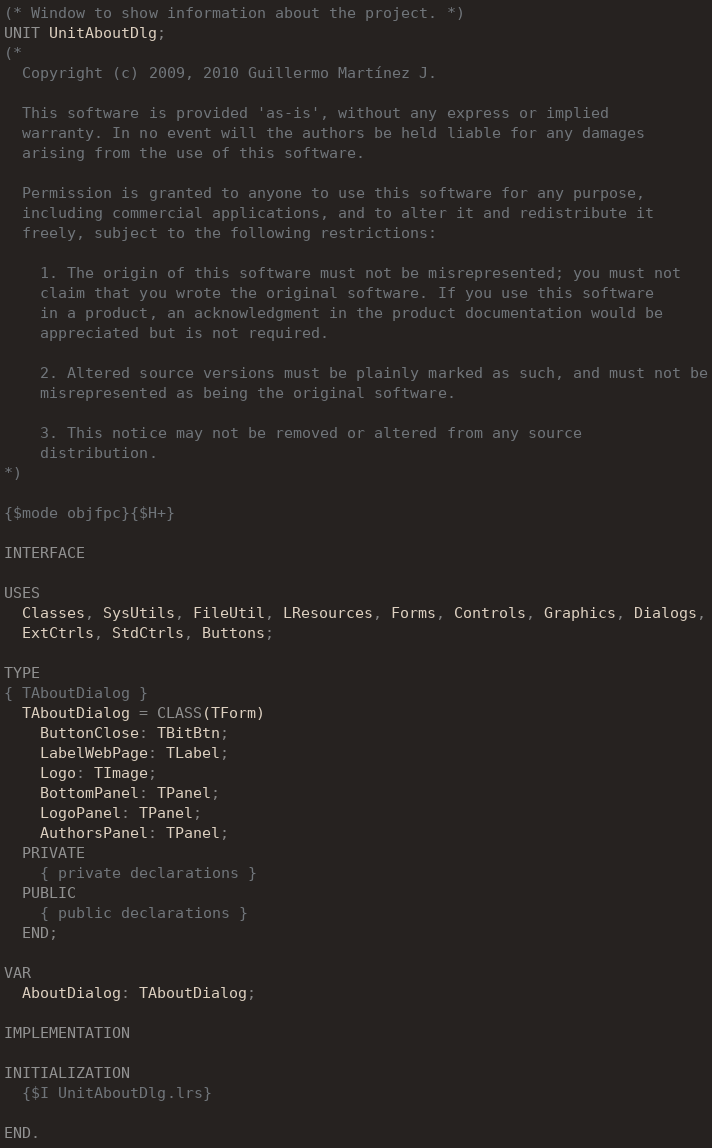Convert code to text. <code><loc_0><loc_0><loc_500><loc_500><_Pascal_>(* Window to show information about the project. *)
UNIT UnitAboutDlg;
(*
  Copyright (c) 2009, 2010 Guillermo Martínez J.

  This software is provided 'as-is', without any express or implied
  warranty. In no event will the authors be held liable for any damages
  arising from the use of this software.

  Permission is granted to anyone to use this software for any purpose,
  including commercial applications, and to alter it and redistribute it
  freely, subject to the following restrictions:

    1. The origin of this software must not be misrepresented; you must not
    claim that you wrote the original software. If you use this software
    in a product, an acknowledgment in the product documentation would be
    appreciated but is not required.

    2. Altered source versions must be plainly marked as such, and must not be
    misrepresented as being the original software.

    3. This notice may not be removed or altered from any source
    distribution.
*)

{$mode objfpc}{$H+}

INTERFACE

USES
  Classes, SysUtils, FileUtil, LResources, Forms, Controls, Graphics, Dialogs,
  ExtCtrls, StdCtrls, Buttons;

TYPE
{ TAboutDialog }
  TAboutDialog = CLASS(TForm)
    ButtonClose: TBitBtn;
    LabelWebPage: TLabel;
    Logo: TImage;
    BottomPanel: TPanel;
    LogoPanel: TPanel;
    AuthorsPanel: TPanel;
  PRIVATE
    { private declarations }
  PUBLIC
    { public declarations }
  END;

VAR
  AboutDialog: TAboutDialog;

IMPLEMENTATION

INITIALIZATION
  {$I UnitAboutDlg.lrs}

END.

</code> 